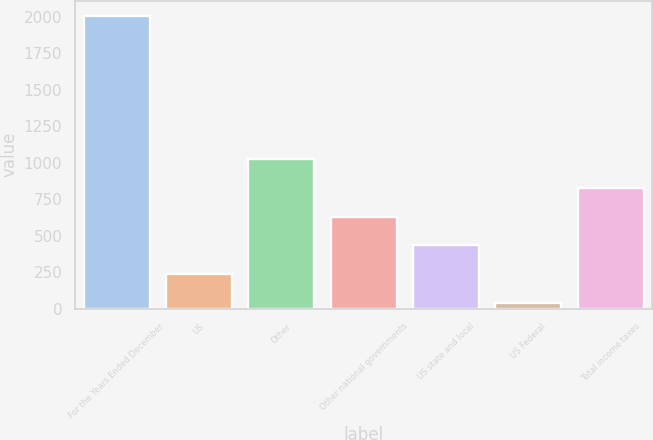Convert chart. <chart><loc_0><loc_0><loc_500><loc_500><bar_chart><fcel>For the Years Ended December<fcel>US<fcel>Other<fcel>Other national governments<fcel>US state and local<fcel>US Federal<fcel>Total income taxes<nl><fcel>2007<fcel>235.8<fcel>1023<fcel>629.4<fcel>432.6<fcel>39<fcel>826.2<nl></chart> 